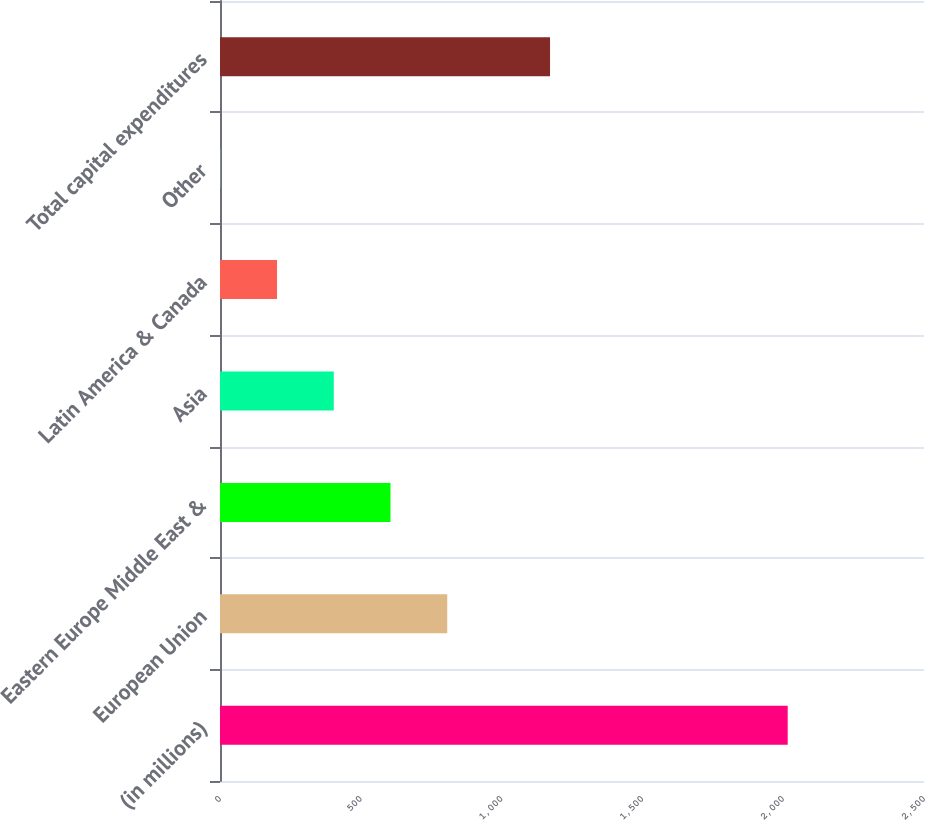Convert chart to OTSL. <chart><loc_0><loc_0><loc_500><loc_500><bar_chart><fcel>(in millions)<fcel>European Union<fcel>Eastern Europe Middle East &<fcel>Asia<fcel>Latin America & Canada<fcel>Other<fcel>Total capital expenditures<nl><fcel>2016<fcel>807<fcel>605.5<fcel>404<fcel>202.5<fcel>1<fcel>1172<nl></chart> 